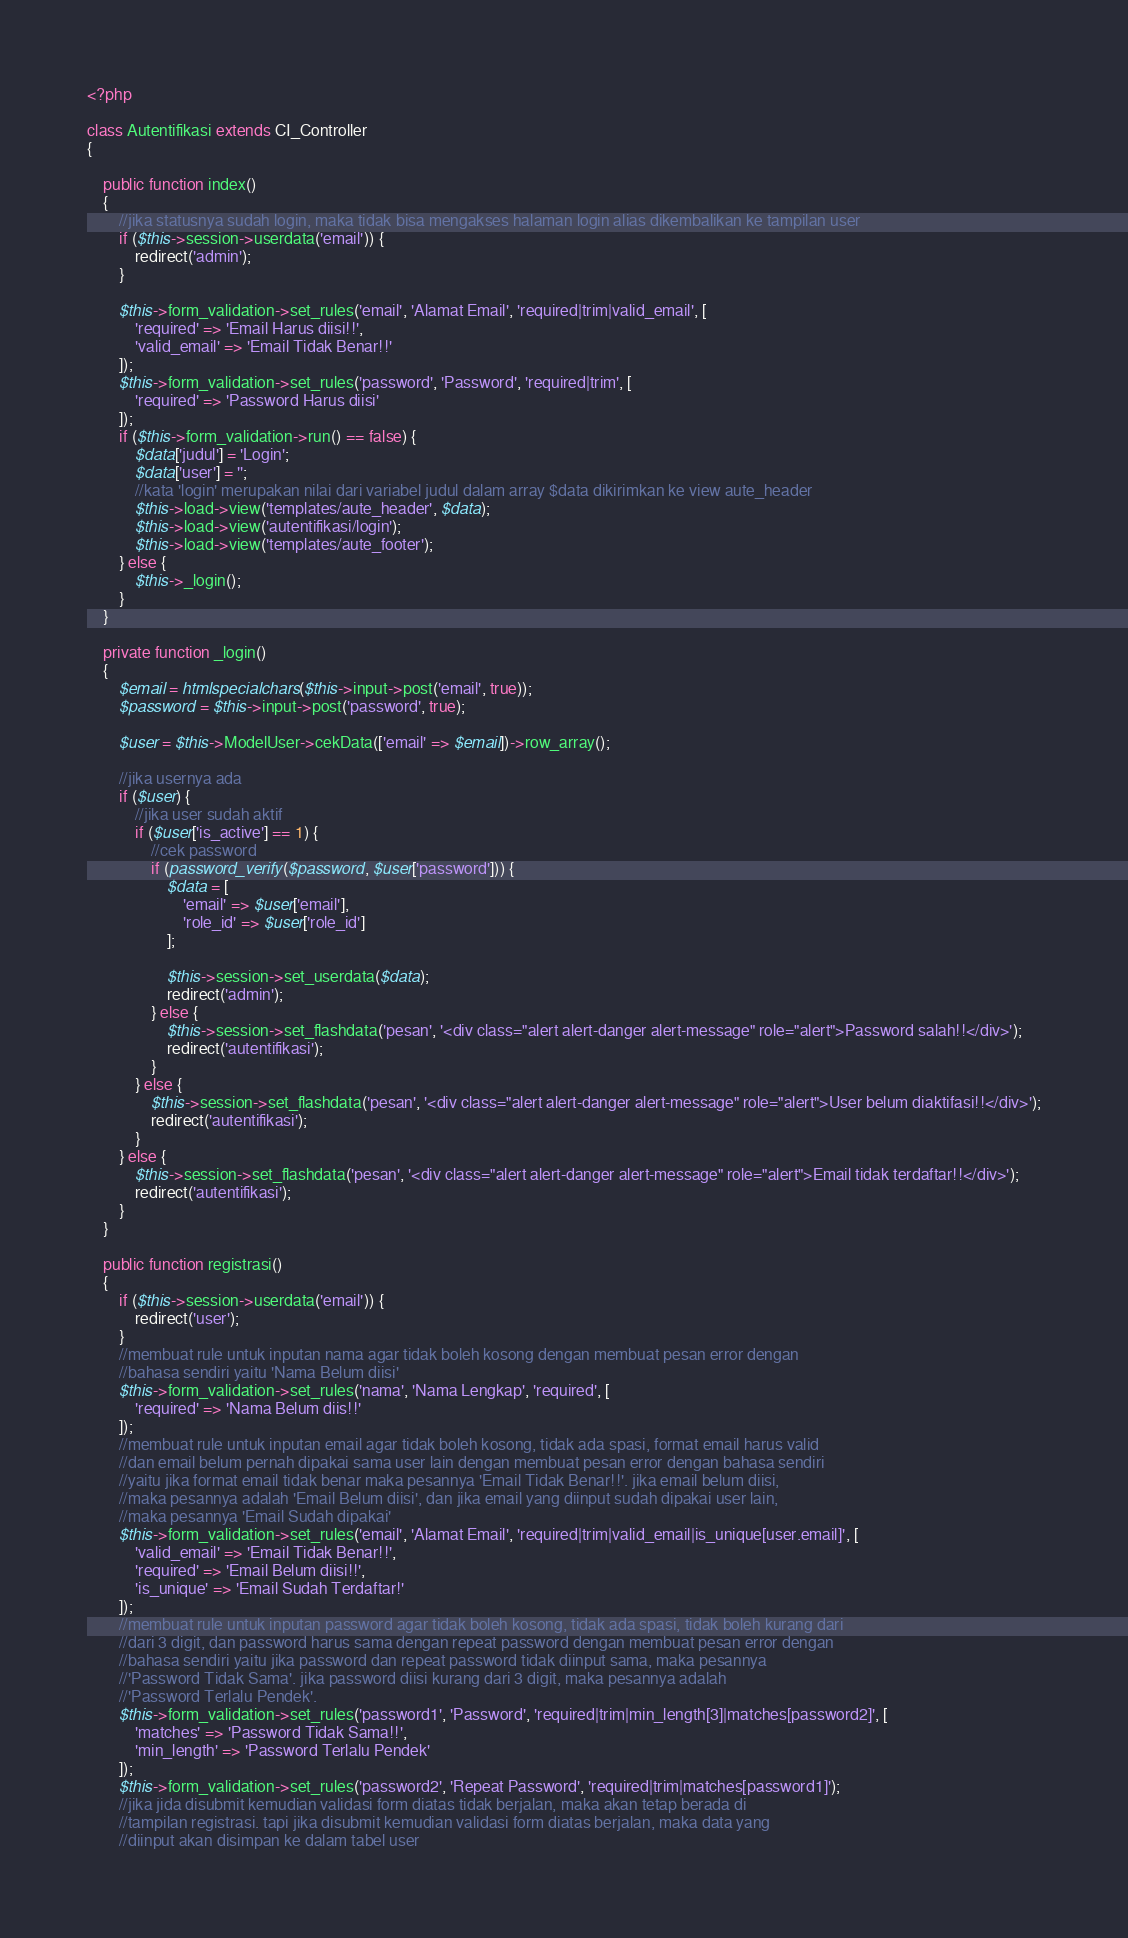<code> <loc_0><loc_0><loc_500><loc_500><_PHP_><?php

class Autentifikasi extends CI_Controller
{

    public function index()
    {
        //jika statusnya sudah login, maka tidak bisa mengakses halaman login alias dikembalikan ke tampilan user
        if ($this->session->userdata('email')) {
            redirect('admin');
        }

        $this->form_validation->set_rules('email', 'Alamat Email', 'required|trim|valid_email', [
            'required' => 'Email Harus diisi!!',
            'valid_email' => 'Email Tidak Benar!!'
        ]);
        $this->form_validation->set_rules('password', 'Password', 'required|trim', [
            'required' => 'Password Harus diisi'
        ]);
        if ($this->form_validation->run() == false) {
            $data['judul'] = 'Login';
            $data['user'] = '';
            //kata 'login' merupakan nilai dari variabel judul dalam array $data dikirimkan ke view aute_header
            $this->load->view('templates/aute_header', $data);
            $this->load->view('autentifikasi/login');
            $this->load->view('templates/aute_footer');
        } else {
            $this->_login();
        }
    }

    private function _login()
    {
        $email = htmlspecialchars($this->input->post('email', true));
        $password = $this->input->post('password', true);

        $user = $this->ModelUser->cekData(['email' => $email])->row_array();

        //jika usernya ada
        if ($user) {
            //jika user sudah aktif
            if ($user['is_active'] == 1) {
                //cek password
                if (password_verify($password, $user['password'])) {
                    $data = [
                        'email' => $user['email'],
                        'role_id' => $user['role_id']
                    ];

                    $this->session->set_userdata($data);
                    redirect('admin');
                } else {
                    $this->session->set_flashdata('pesan', '<div class="alert alert-danger alert-message" role="alert">Password salah!!</div>');
                    redirect('autentifikasi');
                }
            } else {
                $this->session->set_flashdata('pesan', '<div class="alert alert-danger alert-message" role="alert">User belum diaktifasi!!</div>');
                redirect('autentifikasi');
            }
        } else {
            $this->session->set_flashdata('pesan', '<div class="alert alert-danger alert-message" role="alert">Email tidak terdaftar!!</div>');
            redirect('autentifikasi');
        }
    }

    public function registrasi()
    {
        if ($this->session->userdata('email')) {
            redirect('user');
        }
        //membuat rule untuk inputan nama agar tidak boleh kosong dengan membuat pesan error dengan 
        //bahasa sendiri yaitu 'Nama Belum diisi'
        $this->form_validation->set_rules('nama', 'Nama Lengkap', 'required', [
            'required' => 'Nama Belum diis!!'
        ]);
        //membuat rule untuk inputan email agar tidak boleh kosong, tidak ada spasi, format email harus valid
        //dan email belum pernah dipakai sama user lain dengan membuat pesan error dengan bahasa sendiri 
        //yaitu jika format email tidak benar maka pesannya 'Email Tidak Benar!!'. jika email belum diisi,
        //maka pesannya adalah 'Email Belum diisi', dan jika email yang diinput sudah dipakai user lain,
        //maka pesannya 'Email Sudah dipakai'
        $this->form_validation->set_rules('email', 'Alamat Email', 'required|trim|valid_email|is_unique[user.email]', [
            'valid_email' => 'Email Tidak Benar!!',
            'required' => 'Email Belum diisi!!',
            'is_unique' => 'Email Sudah Terdaftar!'
        ]);
        //membuat rule untuk inputan password agar tidak boleh kosong, tidak ada spasi, tidak boleh kurang dari
        //dari 3 digit, dan password harus sama dengan repeat password dengan membuat pesan error dengan  
        //bahasa sendiri yaitu jika password dan repeat password tidak diinput sama, maka pesannya
        //'Password Tidak Sama'. jika password diisi kurang dari 3 digit, maka pesannya adalah 
        //'Password Terlalu Pendek'.
        $this->form_validation->set_rules('password1', 'Password', 'required|trim|min_length[3]|matches[password2]', [
            'matches' => 'Password Tidak Sama!!',
            'min_length' => 'Password Terlalu Pendek'
        ]);
        $this->form_validation->set_rules('password2', 'Repeat Password', 'required|trim|matches[password1]');
        //jika jida disubmit kemudian validasi form diatas tidak berjalan, maka akan tetap berada di
        //tampilan registrasi. tapi jika disubmit kemudian validasi form diatas berjalan, maka data yang 
        //diinput akan disimpan ke dalam tabel user</code> 